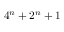<formula> <loc_0><loc_0><loc_500><loc_500>4 ^ { n } + 2 ^ { n } + 1</formula> 